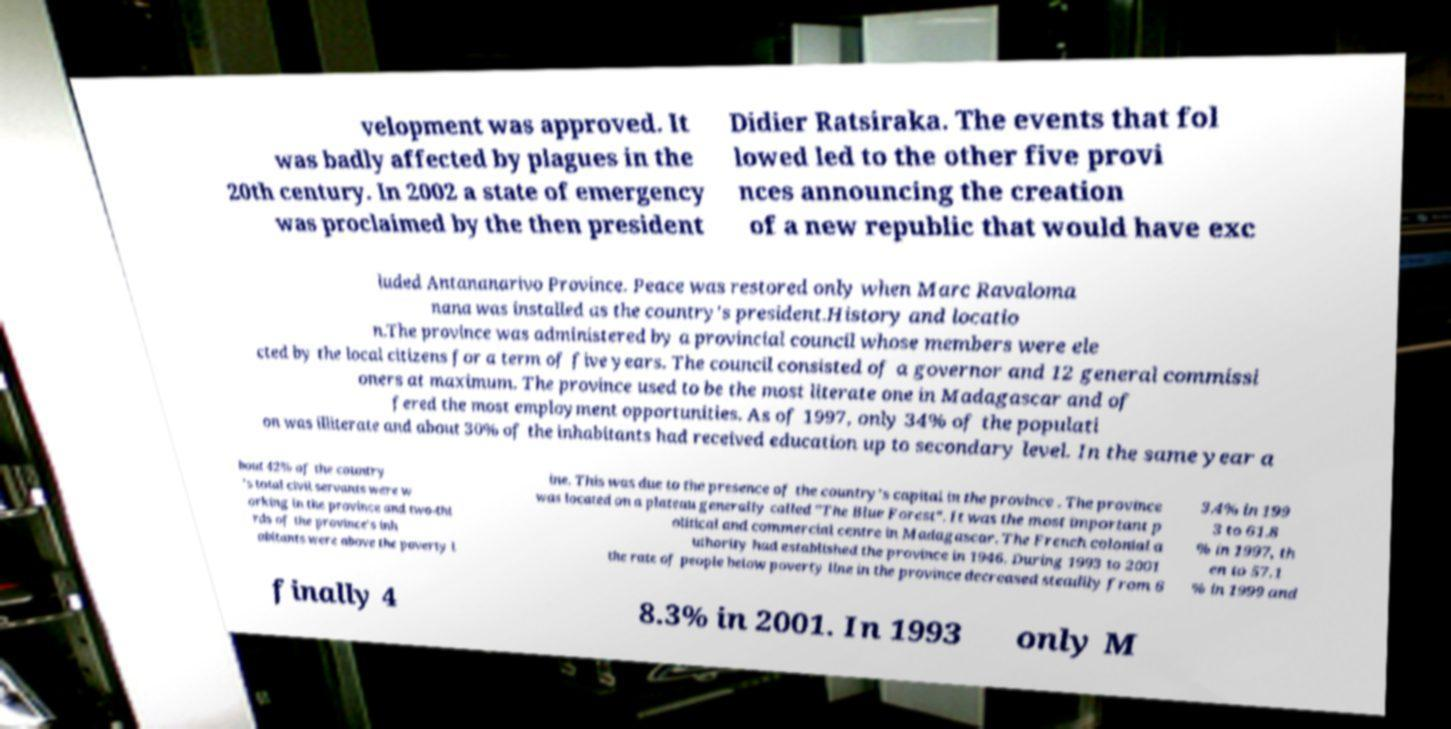I need the written content from this picture converted into text. Can you do that? velopment was approved. It was badly affected by plagues in the 20th century. In 2002 a state of emergency was proclaimed by the then president Didier Ratsiraka. The events that fol lowed led to the other five provi nces announcing the creation of a new republic that would have exc luded Antananarivo Province. Peace was restored only when Marc Ravaloma nana was installed as the country's president.History and locatio n.The province was administered by a provincial council whose members were ele cted by the local citizens for a term of five years. The council consisted of a governor and 12 general commissi oners at maximum. The province used to be the most literate one in Madagascar and of fered the most employment opportunities. As of 1997, only 34% of the populati on was illiterate and about 30% of the inhabitants had received education up to secondary level. In the same year a bout 42% of the country 's total civil servants were w orking in the province and two-thi rds of the province's inh abitants were above the poverty l ine. This was due to the presence of the country's capital in the province . The province was located on a plateau generally called "The Blue Forest". It was the most important p olitical and commercial centre in Madagascar. The French colonial a uthority had established the province in 1946. During 1993 to 2001 the rate of people below poverty line in the province decreased steadily from 6 3.4% in 199 3 to 61.8 % in 1997, th en to 57.1 % in 1999 and finally 4 8.3% in 2001. In 1993 only M 